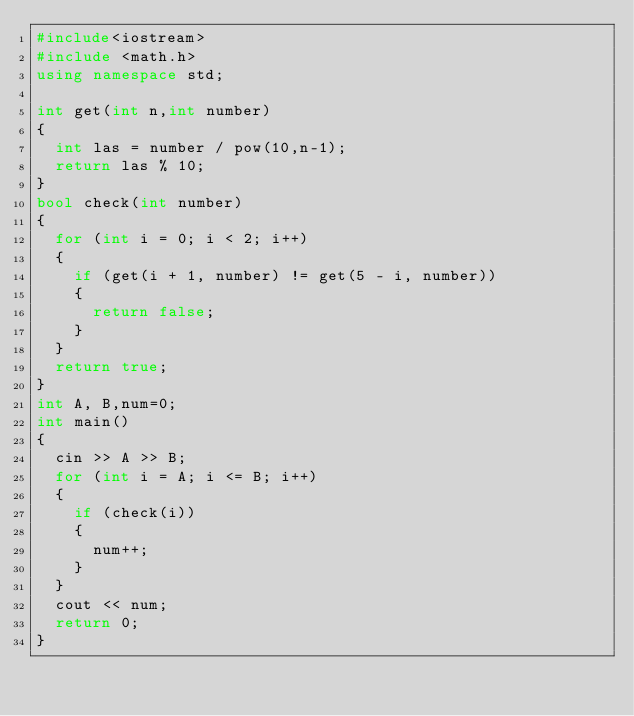Convert code to text. <code><loc_0><loc_0><loc_500><loc_500><_C++_>#include<iostream>
#include <math.h>
using namespace std;

int get(int n,int number)
{
	int las = number / pow(10,n-1);
	return las % 10;
}
bool check(int number)
{
	for (int i = 0; i < 2; i++)
	{
		if (get(i + 1, number) != get(5 - i, number))
		{
			return false;
		}
	}
	return true;
}
int A, B,num=0;
int main()
{
	cin >> A >> B;
	for (int i = A; i <= B; i++)
	{
		if (check(i))
		{
			num++;
		}
	}
	cout << num;
	return 0;
}</code> 